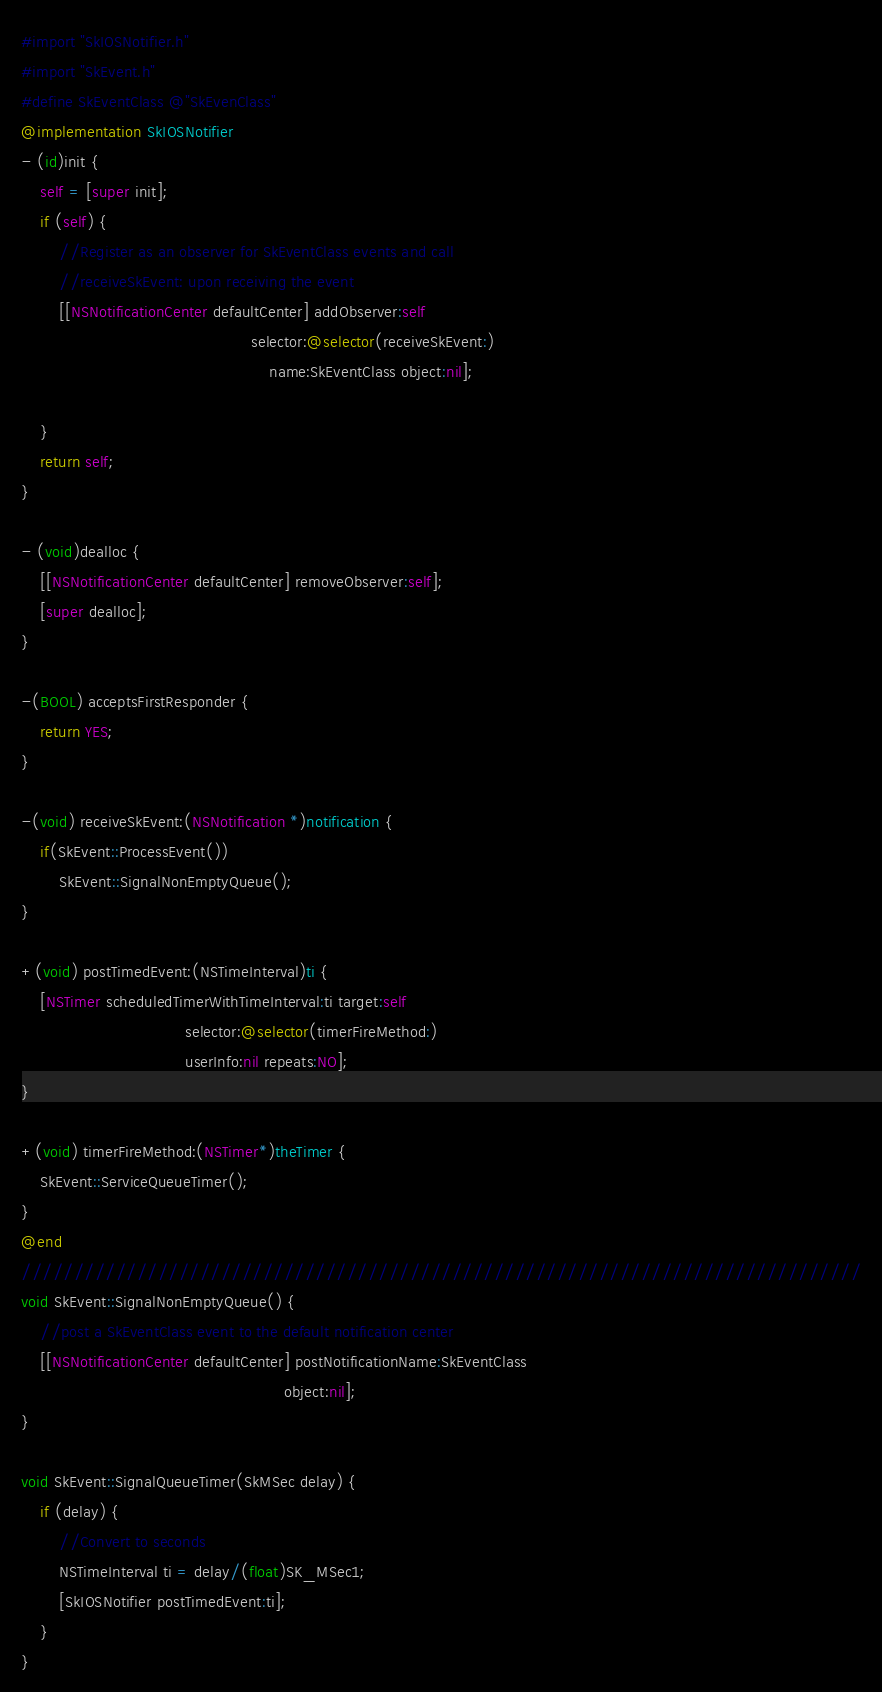<code> <loc_0><loc_0><loc_500><loc_500><_ObjectiveC_>#import "SkIOSNotifier.h"
#import "SkEvent.h"
#define SkEventClass @"SkEvenClass"
@implementation SkIOSNotifier
- (id)init {
    self = [super init];
    if (self) {
        //Register as an observer for SkEventClass events and call 
        //receiveSkEvent: upon receiving the event
        [[NSNotificationCenter defaultCenter] addObserver:self 
                                                 selector:@selector(receiveSkEvent:) 
                                                     name:SkEventClass object:nil];
        
    }
    return self;
}

- (void)dealloc {
    [[NSNotificationCenter defaultCenter] removeObserver:self];
    [super dealloc];
}

-(BOOL) acceptsFirstResponder {
    return YES;
}

-(void) receiveSkEvent:(NSNotification *)notification {
    if(SkEvent::ProcessEvent())
        SkEvent::SignalNonEmptyQueue();
}

+(void) postTimedEvent:(NSTimeInterval)ti {
    [NSTimer scheduledTimerWithTimeInterval:ti target:self 
                                   selector:@selector(timerFireMethod:)
                                   userInfo:nil repeats:NO];
}

+(void) timerFireMethod:(NSTimer*)theTimer {
	SkEvent::ServiceQueueTimer();
}
@end
////////////////////////////////////////////////////////////////////////////////
void SkEvent::SignalNonEmptyQueue() {
    //post a SkEventClass event to the default notification center
    [[NSNotificationCenter defaultCenter] postNotificationName:SkEventClass 
                                                        object:nil];
}

void SkEvent::SignalQueueTimer(SkMSec delay) {
	if (delay) {
        //Convert to seconds
        NSTimeInterval ti = delay/(float)SK_MSec1;
        [SkIOSNotifier postTimedEvent:ti];
	}  
}</code> 